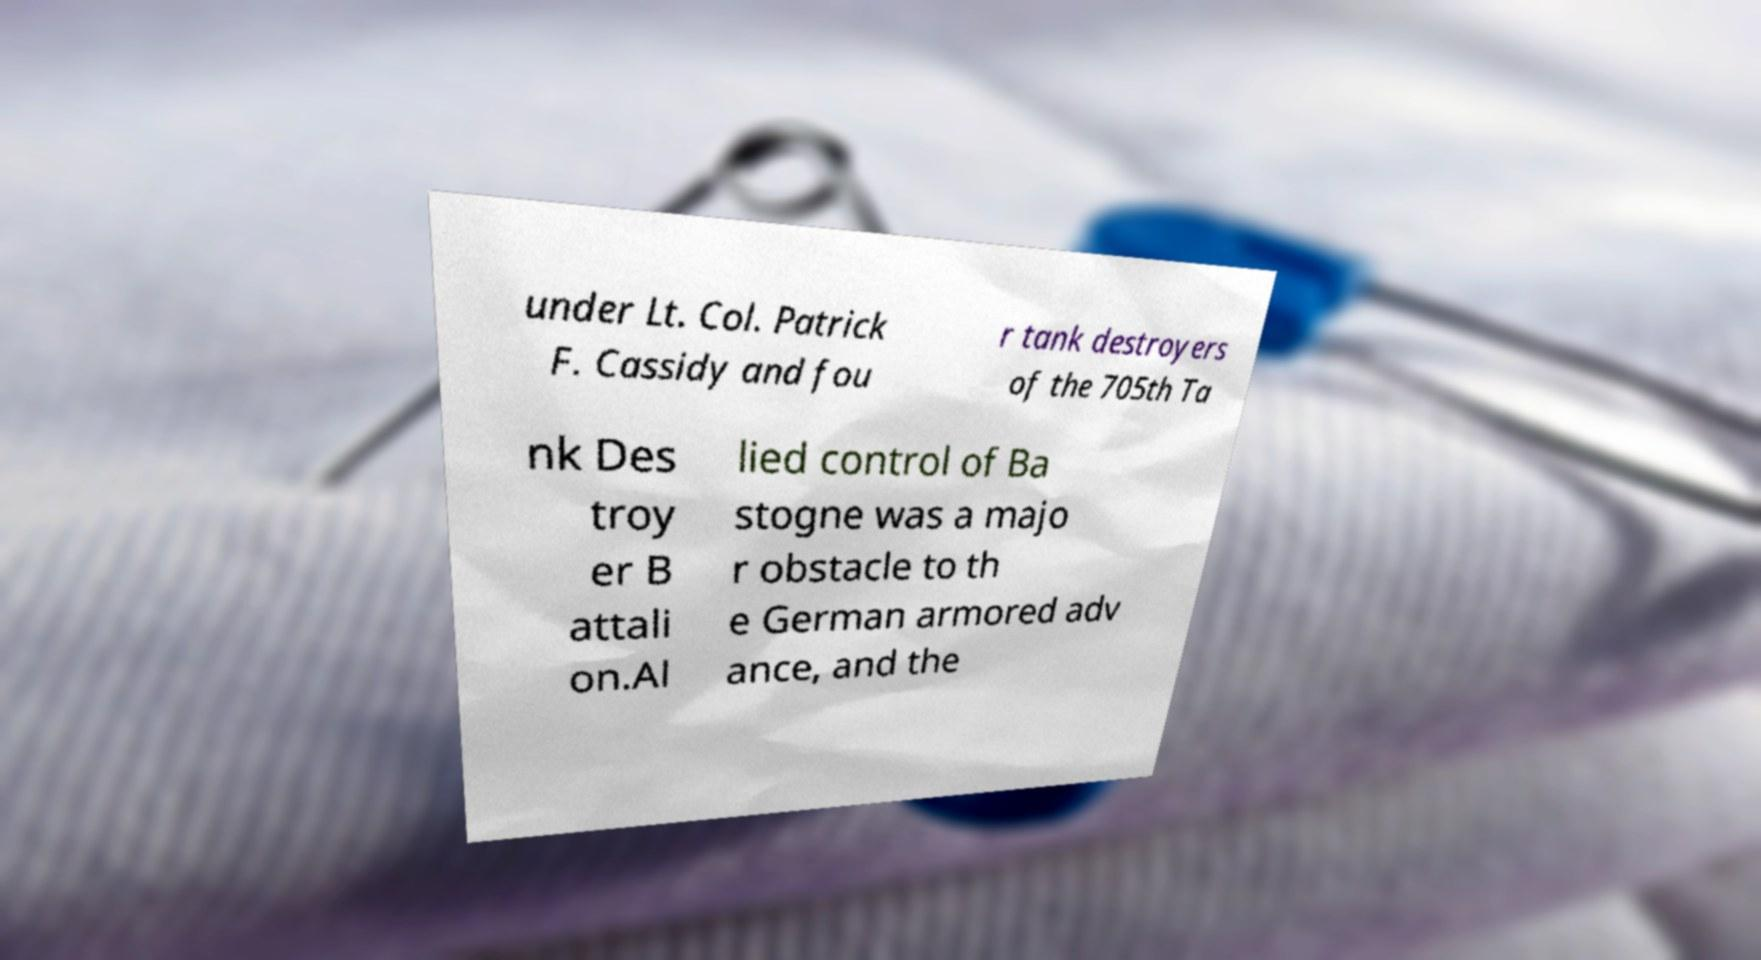Can you accurately transcribe the text from the provided image for me? under Lt. Col. Patrick F. Cassidy and fou r tank destroyers of the 705th Ta nk Des troy er B attali on.Al lied control of Ba stogne was a majo r obstacle to th e German armored adv ance, and the 